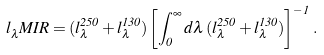Convert formula to latex. <formula><loc_0><loc_0><loc_500><loc_500>l _ { \lambda } ^ { \, } M I R = ( l _ { \lambda } ^ { 2 5 0 } + l _ { \lambda } ^ { 1 3 0 } ) \left [ \int _ { 0 } ^ { \infty } d \lambda \, ( l _ { \lambda } ^ { 2 5 0 } + l _ { \lambda } ^ { 1 3 0 } ) \right ] ^ { - 1 } \, .</formula> 